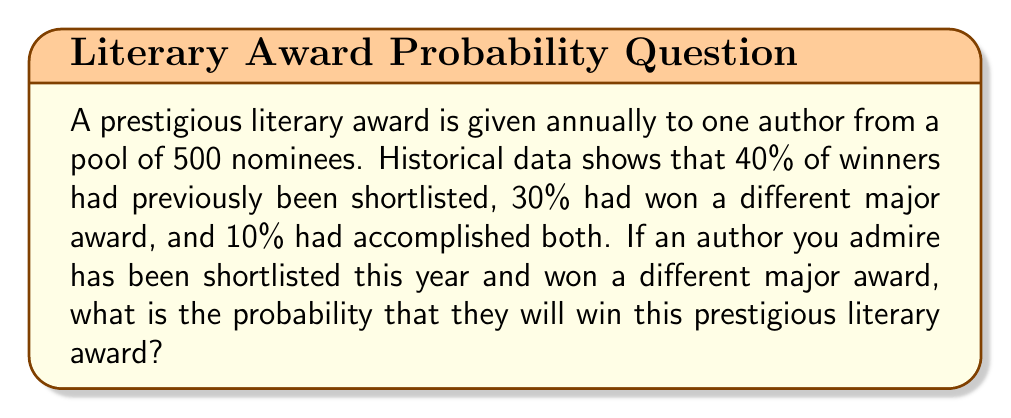Solve this math problem. Let's approach this step-by-step using probability theory:

1) Define events:
   A: Author has been shortlisted
   B: Author has won a different major award
   W: Author wins the prestigious literary award

2) Given probabilities:
   P(W|A) = 0.40 (40% of winners had been shortlisted)
   P(W|B) = 0.30 (30% of winners had won a different major award)
   P(W|A∩B) = 0.10 (10% of winners had accomplished both)

3) We need to find P(W|A∩B), which is already given as 0.10.

4) However, to understand why this is the correct answer, let's break it down further:

   The probability of winning given both conditions is not simply the sum or product of individual probabilities. This is because the events are not independent.

5) We can verify this using Bayes' theorem:

   $$P(W|A∩B) = \frac{P(A∩B|W) \cdot P(W)}{P(A∩B)}$$

6) We don't have all these probabilities, but we know that P(W|A∩B) = 0.10

7) This probability accounts for the increased likelihood of winning due to meeting both criteria, while also considering that these criteria are not independent predictors of winning.

Therefore, the probability that the admired author will win the prestigious literary award, given that they have been shortlisted and won a different major award, is 0.10 or 10%.
Answer: 0.10 or 10% 